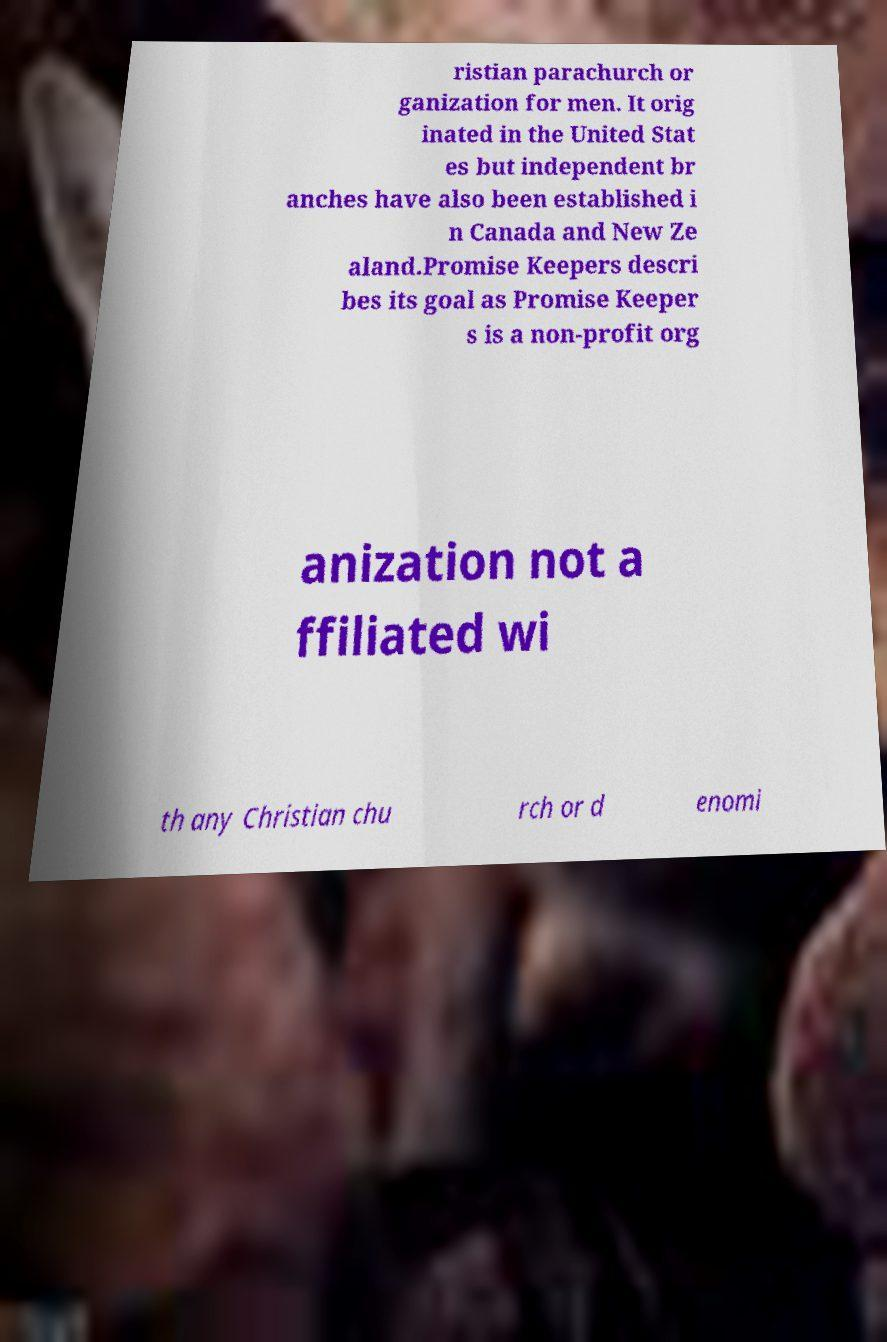What messages or text are displayed in this image? I need them in a readable, typed format. ristian parachurch or ganization for men. It orig inated in the United Stat es but independent br anches have also been established i n Canada and New Ze aland.Promise Keepers descri bes its goal as Promise Keeper s is a non-profit org anization not a ffiliated wi th any Christian chu rch or d enomi 